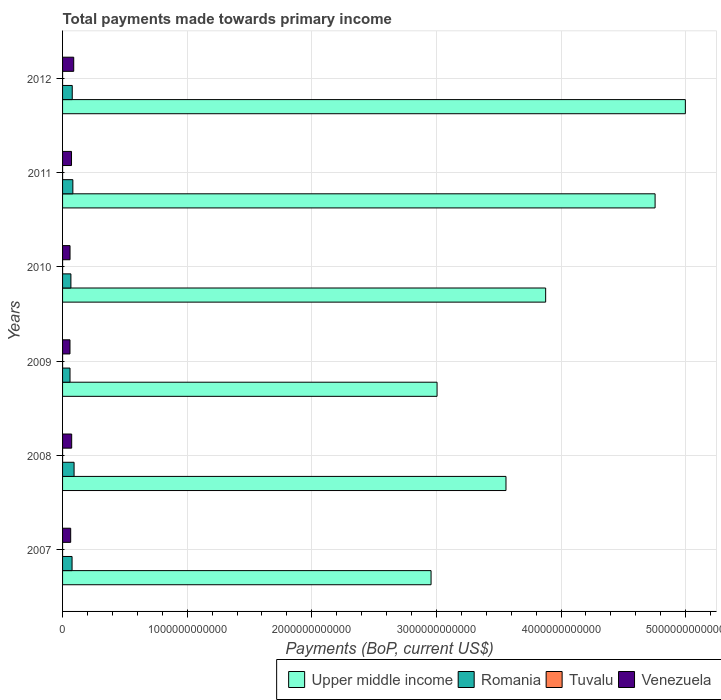How many groups of bars are there?
Keep it short and to the point. 6. Are the number of bars per tick equal to the number of legend labels?
Provide a short and direct response. Yes. Are the number of bars on each tick of the Y-axis equal?
Your response must be concise. Yes. How many bars are there on the 5th tick from the bottom?
Keep it short and to the point. 4. In how many cases, is the number of bars for a given year not equal to the number of legend labels?
Provide a short and direct response. 0. What is the total payments made towards primary income in Venezuela in 2010?
Provide a succinct answer. 5.99e+1. Across all years, what is the maximum total payments made towards primary income in Upper middle income?
Offer a terse response. 5.00e+12. Across all years, what is the minimum total payments made towards primary income in Romania?
Provide a succinct answer. 5.98e+1. In which year was the total payments made towards primary income in Tuvalu maximum?
Offer a very short reply. 2011. In which year was the total payments made towards primary income in Romania minimum?
Provide a short and direct response. 2009. What is the total total payments made towards primary income in Upper middle income in the graph?
Give a very brief answer. 2.32e+13. What is the difference between the total payments made towards primary income in Romania in 2008 and that in 2011?
Offer a very short reply. 9.68e+09. What is the difference between the total payments made towards primary income in Romania in 2009 and the total payments made towards primary income in Tuvalu in 2012?
Keep it short and to the point. 5.98e+1. What is the average total payments made towards primary income in Venezuela per year?
Provide a succinct answer. 6.99e+1. In the year 2012, what is the difference between the total payments made towards primary income in Tuvalu and total payments made towards primary income in Venezuela?
Offer a terse response. -8.95e+1. What is the ratio of the total payments made towards primary income in Tuvalu in 2008 to that in 2010?
Offer a terse response. 0.74. What is the difference between the highest and the second highest total payments made towards primary income in Tuvalu?
Offer a terse response. 1.28e+07. What is the difference between the highest and the lowest total payments made towards primary income in Venezuela?
Give a very brief answer. 3.00e+1. In how many years, is the total payments made towards primary income in Venezuela greater than the average total payments made towards primary income in Venezuela taken over all years?
Keep it short and to the point. 3. Is the sum of the total payments made towards primary income in Upper middle income in 2010 and 2012 greater than the maximum total payments made towards primary income in Tuvalu across all years?
Your response must be concise. Yes. Is it the case that in every year, the sum of the total payments made towards primary income in Tuvalu and total payments made towards primary income in Upper middle income is greater than the sum of total payments made towards primary income in Venezuela and total payments made towards primary income in Romania?
Keep it short and to the point. Yes. What does the 4th bar from the top in 2009 represents?
Your answer should be compact. Upper middle income. What does the 1st bar from the bottom in 2010 represents?
Offer a terse response. Upper middle income. Is it the case that in every year, the sum of the total payments made towards primary income in Upper middle income and total payments made towards primary income in Tuvalu is greater than the total payments made towards primary income in Venezuela?
Give a very brief answer. Yes. How many bars are there?
Offer a terse response. 24. Are all the bars in the graph horizontal?
Offer a terse response. Yes. How many years are there in the graph?
Provide a succinct answer. 6. What is the difference between two consecutive major ticks on the X-axis?
Your answer should be compact. 1.00e+12. Are the values on the major ticks of X-axis written in scientific E-notation?
Provide a succinct answer. No. Does the graph contain grids?
Give a very brief answer. Yes. How are the legend labels stacked?
Your answer should be very brief. Horizontal. What is the title of the graph?
Your answer should be compact. Total payments made towards primary income. What is the label or title of the X-axis?
Your response must be concise. Payments (BoP, current US$). What is the label or title of the Y-axis?
Provide a short and direct response. Years. What is the Payments (BoP, current US$) of Upper middle income in 2007?
Your answer should be compact. 2.96e+12. What is the Payments (BoP, current US$) in Romania in 2007?
Provide a succinct answer. 7.62e+1. What is the Payments (BoP, current US$) of Tuvalu in 2007?
Offer a very short reply. 3.24e+07. What is the Payments (BoP, current US$) in Venezuela in 2007?
Give a very brief answer. 6.52e+1. What is the Payments (BoP, current US$) of Upper middle income in 2008?
Provide a succinct answer. 3.56e+12. What is the Payments (BoP, current US$) of Romania in 2008?
Offer a terse response. 9.23e+1. What is the Payments (BoP, current US$) of Tuvalu in 2008?
Ensure brevity in your answer.  4.03e+07. What is the Payments (BoP, current US$) in Venezuela in 2008?
Make the answer very short. 7.31e+1. What is the Payments (BoP, current US$) in Upper middle income in 2009?
Make the answer very short. 3.01e+12. What is the Payments (BoP, current US$) in Romania in 2009?
Provide a succinct answer. 5.98e+1. What is the Payments (BoP, current US$) of Tuvalu in 2009?
Offer a terse response. 5.19e+07. What is the Payments (BoP, current US$) in Venezuela in 2009?
Your response must be concise. 5.95e+1. What is the Payments (BoP, current US$) in Upper middle income in 2010?
Give a very brief answer. 3.88e+12. What is the Payments (BoP, current US$) in Romania in 2010?
Give a very brief answer. 6.70e+1. What is the Payments (BoP, current US$) in Tuvalu in 2010?
Ensure brevity in your answer.  5.47e+07. What is the Payments (BoP, current US$) of Venezuela in 2010?
Offer a terse response. 5.99e+1. What is the Payments (BoP, current US$) of Upper middle income in 2011?
Your answer should be compact. 4.76e+12. What is the Payments (BoP, current US$) in Romania in 2011?
Offer a terse response. 8.27e+1. What is the Payments (BoP, current US$) in Tuvalu in 2011?
Give a very brief answer. 6.75e+07. What is the Payments (BoP, current US$) of Venezuela in 2011?
Provide a short and direct response. 7.19e+1. What is the Payments (BoP, current US$) of Upper middle income in 2012?
Your answer should be compact. 5.00e+12. What is the Payments (BoP, current US$) in Romania in 2012?
Your answer should be compact. 7.77e+1. What is the Payments (BoP, current US$) in Tuvalu in 2012?
Ensure brevity in your answer.  5.44e+07. What is the Payments (BoP, current US$) in Venezuela in 2012?
Provide a succinct answer. 8.95e+1. Across all years, what is the maximum Payments (BoP, current US$) in Upper middle income?
Your answer should be compact. 5.00e+12. Across all years, what is the maximum Payments (BoP, current US$) of Romania?
Provide a succinct answer. 9.23e+1. Across all years, what is the maximum Payments (BoP, current US$) of Tuvalu?
Keep it short and to the point. 6.75e+07. Across all years, what is the maximum Payments (BoP, current US$) of Venezuela?
Offer a very short reply. 8.95e+1. Across all years, what is the minimum Payments (BoP, current US$) in Upper middle income?
Provide a short and direct response. 2.96e+12. Across all years, what is the minimum Payments (BoP, current US$) in Romania?
Provide a succinct answer. 5.98e+1. Across all years, what is the minimum Payments (BoP, current US$) of Tuvalu?
Your response must be concise. 3.24e+07. Across all years, what is the minimum Payments (BoP, current US$) of Venezuela?
Your answer should be compact. 5.95e+1. What is the total Payments (BoP, current US$) in Upper middle income in the graph?
Provide a succinct answer. 2.32e+13. What is the total Payments (BoP, current US$) of Romania in the graph?
Provide a short and direct response. 4.56e+11. What is the total Payments (BoP, current US$) of Tuvalu in the graph?
Provide a short and direct response. 3.01e+08. What is the total Payments (BoP, current US$) in Venezuela in the graph?
Keep it short and to the point. 4.19e+11. What is the difference between the Payments (BoP, current US$) in Upper middle income in 2007 and that in 2008?
Make the answer very short. -6.01e+11. What is the difference between the Payments (BoP, current US$) in Romania in 2007 and that in 2008?
Your answer should be compact. -1.61e+1. What is the difference between the Payments (BoP, current US$) of Tuvalu in 2007 and that in 2008?
Provide a short and direct response. -7.85e+06. What is the difference between the Payments (BoP, current US$) in Venezuela in 2007 and that in 2008?
Offer a very short reply. -7.94e+09. What is the difference between the Payments (BoP, current US$) of Upper middle income in 2007 and that in 2009?
Your response must be concise. -4.81e+1. What is the difference between the Payments (BoP, current US$) of Romania in 2007 and that in 2009?
Ensure brevity in your answer.  1.64e+1. What is the difference between the Payments (BoP, current US$) of Tuvalu in 2007 and that in 2009?
Provide a short and direct response. -1.95e+07. What is the difference between the Payments (BoP, current US$) in Venezuela in 2007 and that in 2009?
Provide a short and direct response. 5.68e+09. What is the difference between the Payments (BoP, current US$) of Upper middle income in 2007 and that in 2010?
Make the answer very short. -9.20e+11. What is the difference between the Payments (BoP, current US$) in Romania in 2007 and that in 2010?
Keep it short and to the point. 9.24e+09. What is the difference between the Payments (BoP, current US$) of Tuvalu in 2007 and that in 2010?
Give a very brief answer. -2.22e+07. What is the difference between the Payments (BoP, current US$) in Venezuela in 2007 and that in 2010?
Keep it short and to the point. 5.32e+09. What is the difference between the Payments (BoP, current US$) in Upper middle income in 2007 and that in 2011?
Make the answer very short. -1.80e+12. What is the difference between the Payments (BoP, current US$) of Romania in 2007 and that in 2011?
Offer a very short reply. -6.46e+09. What is the difference between the Payments (BoP, current US$) of Tuvalu in 2007 and that in 2011?
Make the answer very short. -3.51e+07. What is the difference between the Payments (BoP, current US$) in Venezuela in 2007 and that in 2011?
Keep it short and to the point. -6.66e+09. What is the difference between the Payments (BoP, current US$) of Upper middle income in 2007 and that in 2012?
Provide a short and direct response. -2.04e+12. What is the difference between the Payments (BoP, current US$) in Romania in 2007 and that in 2012?
Provide a short and direct response. -1.47e+09. What is the difference between the Payments (BoP, current US$) of Tuvalu in 2007 and that in 2012?
Your response must be concise. -2.20e+07. What is the difference between the Payments (BoP, current US$) in Venezuela in 2007 and that in 2012?
Provide a short and direct response. -2.43e+1. What is the difference between the Payments (BoP, current US$) in Upper middle income in 2008 and that in 2009?
Give a very brief answer. 5.53e+11. What is the difference between the Payments (BoP, current US$) of Romania in 2008 and that in 2009?
Your answer should be compact. 3.25e+1. What is the difference between the Payments (BoP, current US$) of Tuvalu in 2008 and that in 2009?
Offer a terse response. -1.16e+07. What is the difference between the Payments (BoP, current US$) of Venezuela in 2008 and that in 2009?
Keep it short and to the point. 1.36e+1. What is the difference between the Payments (BoP, current US$) in Upper middle income in 2008 and that in 2010?
Make the answer very short. -3.18e+11. What is the difference between the Payments (BoP, current US$) in Romania in 2008 and that in 2010?
Provide a succinct answer. 2.54e+1. What is the difference between the Payments (BoP, current US$) of Tuvalu in 2008 and that in 2010?
Provide a short and direct response. -1.44e+07. What is the difference between the Payments (BoP, current US$) of Venezuela in 2008 and that in 2010?
Offer a very short reply. 1.33e+1. What is the difference between the Payments (BoP, current US$) in Upper middle income in 2008 and that in 2011?
Your answer should be very brief. -1.20e+12. What is the difference between the Payments (BoP, current US$) of Romania in 2008 and that in 2011?
Offer a terse response. 9.68e+09. What is the difference between the Payments (BoP, current US$) in Tuvalu in 2008 and that in 2011?
Give a very brief answer. -2.72e+07. What is the difference between the Payments (BoP, current US$) in Venezuela in 2008 and that in 2011?
Give a very brief answer. 1.28e+09. What is the difference between the Payments (BoP, current US$) in Upper middle income in 2008 and that in 2012?
Offer a very short reply. -1.44e+12. What is the difference between the Payments (BoP, current US$) in Romania in 2008 and that in 2012?
Your answer should be very brief. 1.47e+1. What is the difference between the Payments (BoP, current US$) of Tuvalu in 2008 and that in 2012?
Your answer should be compact. -1.41e+07. What is the difference between the Payments (BoP, current US$) of Venezuela in 2008 and that in 2012?
Your answer should be compact. -1.64e+1. What is the difference between the Payments (BoP, current US$) of Upper middle income in 2009 and that in 2010?
Your response must be concise. -8.71e+11. What is the difference between the Payments (BoP, current US$) in Romania in 2009 and that in 2010?
Your answer should be compact. -7.15e+09. What is the difference between the Payments (BoP, current US$) in Tuvalu in 2009 and that in 2010?
Offer a terse response. -2.75e+06. What is the difference between the Payments (BoP, current US$) of Venezuela in 2009 and that in 2010?
Provide a short and direct response. -3.62e+08. What is the difference between the Payments (BoP, current US$) in Upper middle income in 2009 and that in 2011?
Make the answer very short. -1.75e+12. What is the difference between the Payments (BoP, current US$) in Romania in 2009 and that in 2011?
Your answer should be compact. -2.29e+1. What is the difference between the Payments (BoP, current US$) in Tuvalu in 2009 and that in 2011?
Offer a terse response. -1.56e+07. What is the difference between the Payments (BoP, current US$) in Venezuela in 2009 and that in 2011?
Offer a very short reply. -1.23e+1. What is the difference between the Payments (BoP, current US$) in Upper middle income in 2009 and that in 2012?
Give a very brief answer. -1.99e+12. What is the difference between the Payments (BoP, current US$) of Romania in 2009 and that in 2012?
Offer a very short reply. -1.79e+1. What is the difference between the Payments (BoP, current US$) of Tuvalu in 2009 and that in 2012?
Provide a succinct answer. -2.47e+06. What is the difference between the Payments (BoP, current US$) of Venezuela in 2009 and that in 2012?
Your answer should be very brief. -3.00e+1. What is the difference between the Payments (BoP, current US$) of Upper middle income in 2010 and that in 2011?
Keep it short and to the point. -8.78e+11. What is the difference between the Payments (BoP, current US$) of Romania in 2010 and that in 2011?
Keep it short and to the point. -1.57e+1. What is the difference between the Payments (BoP, current US$) of Tuvalu in 2010 and that in 2011?
Offer a terse response. -1.28e+07. What is the difference between the Payments (BoP, current US$) in Venezuela in 2010 and that in 2011?
Give a very brief answer. -1.20e+1. What is the difference between the Payments (BoP, current US$) in Upper middle income in 2010 and that in 2012?
Give a very brief answer. -1.12e+12. What is the difference between the Payments (BoP, current US$) of Romania in 2010 and that in 2012?
Provide a short and direct response. -1.07e+1. What is the difference between the Payments (BoP, current US$) of Tuvalu in 2010 and that in 2012?
Your answer should be very brief. 2.85e+05. What is the difference between the Payments (BoP, current US$) in Venezuela in 2010 and that in 2012?
Your answer should be very brief. -2.97e+1. What is the difference between the Payments (BoP, current US$) of Upper middle income in 2011 and that in 2012?
Provide a short and direct response. -2.43e+11. What is the difference between the Payments (BoP, current US$) in Romania in 2011 and that in 2012?
Keep it short and to the point. 4.99e+09. What is the difference between the Payments (BoP, current US$) of Tuvalu in 2011 and that in 2012?
Your response must be concise. 1.31e+07. What is the difference between the Payments (BoP, current US$) of Venezuela in 2011 and that in 2012?
Give a very brief answer. -1.77e+1. What is the difference between the Payments (BoP, current US$) in Upper middle income in 2007 and the Payments (BoP, current US$) in Romania in 2008?
Your answer should be compact. 2.86e+12. What is the difference between the Payments (BoP, current US$) in Upper middle income in 2007 and the Payments (BoP, current US$) in Tuvalu in 2008?
Ensure brevity in your answer.  2.96e+12. What is the difference between the Payments (BoP, current US$) in Upper middle income in 2007 and the Payments (BoP, current US$) in Venezuela in 2008?
Keep it short and to the point. 2.88e+12. What is the difference between the Payments (BoP, current US$) of Romania in 2007 and the Payments (BoP, current US$) of Tuvalu in 2008?
Give a very brief answer. 7.62e+1. What is the difference between the Payments (BoP, current US$) of Romania in 2007 and the Payments (BoP, current US$) of Venezuela in 2008?
Give a very brief answer. 3.06e+09. What is the difference between the Payments (BoP, current US$) of Tuvalu in 2007 and the Payments (BoP, current US$) of Venezuela in 2008?
Provide a succinct answer. -7.31e+1. What is the difference between the Payments (BoP, current US$) of Upper middle income in 2007 and the Payments (BoP, current US$) of Romania in 2009?
Provide a succinct answer. 2.90e+12. What is the difference between the Payments (BoP, current US$) in Upper middle income in 2007 and the Payments (BoP, current US$) in Tuvalu in 2009?
Your answer should be very brief. 2.96e+12. What is the difference between the Payments (BoP, current US$) of Upper middle income in 2007 and the Payments (BoP, current US$) of Venezuela in 2009?
Keep it short and to the point. 2.90e+12. What is the difference between the Payments (BoP, current US$) in Romania in 2007 and the Payments (BoP, current US$) in Tuvalu in 2009?
Give a very brief answer. 7.62e+1. What is the difference between the Payments (BoP, current US$) in Romania in 2007 and the Payments (BoP, current US$) in Venezuela in 2009?
Your answer should be compact. 1.67e+1. What is the difference between the Payments (BoP, current US$) in Tuvalu in 2007 and the Payments (BoP, current US$) in Venezuela in 2009?
Your response must be concise. -5.95e+1. What is the difference between the Payments (BoP, current US$) in Upper middle income in 2007 and the Payments (BoP, current US$) in Romania in 2010?
Offer a terse response. 2.89e+12. What is the difference between the Payments (BoP, current US$) of Upper middle income in 2007 and the Payments (BoP, current US$) of Tuvalu in 2010?
Ensure brevity in your answer.  2.96e+12. What is the difference between the Payments (BoP, current US$) of Upper middle income in 2007 and the Payments (BoP, current US$) of Venezuela in 2010?
Your response must be concise. 2.90e+12. What is the difference between the Payments (BoP, current US$) in Romania in 2007 and the Payments (BoP, current US$) in Tuvalu in 2010?
Make the answer very short. 7.62e+1. What is the difference between the Payments (BoP, current US$) of Romania in 2007 and the Payments (BoP, current US$) of Venezuela in 2010?
Make the answer very short. 1.63e+1. What is the difference between the Payments (BoP, current US$) of Tuvalu in 2007 and the Payments (BoP, current US$) of Venezuela in 2010?
Make the answer very short. -5.98e+1. What is the difference between the Payments (BoP, current US$) of Upper middle income in 2007 and the Payments (BoP, current US$) of Romania in 2011?
Your answer should be compact. 2.87e+12. What is the difference between the Payments (BoP, current US$) of Upper middle income in 2007 and the Payments (BoP, current US$) of Tuvalu in 2011?
Your answer should be compact. 2.96e+12. What is the difference between the Payments (BoP, current US$) in Upper middle income in 2007 and the Payments (BoP, current US$) in Venezuela in 2011?
Give a very brief answer. 2.89e+12. What is the difference between the Payments (BoP, current US$) of Romania in 2007 and the Payments (BoP, current US$) of Tuvalu in 2011?
Keep it short and to the point. 7.61e+1. What is the difference between the Payments (BoP, current US$) of Romania in 2007 and the Payments (BoP, current US$) of Venezuela in 2011?
Offer a terse response. 4.34e+09. What is the difference between the Payments (BoP, current US$) in Tuvalu in 2007 and the Payments (BoP, current US$) in Venezuela in 2011?
Make the answer very short. -7.18e+1. What is the difference between the Payments (BoP, current US$) in Upper middle income in 2007 and the Payments (BoP, current US$) in Romania in 2012?
Your answer should be compact. 2.88e+12. What is the difference between the Payments (BoP, current US$) of Upper middle income in 2007 and the Payments (BoP, current US$) of Tuvalu in 2012?
Give a very brief answer. 2.96e+12. What is the difference between the Payments (BoP, current US$) in Upper middle income in 2007 and the Payments (BoP, current US$) in Venezuela in 2012?
Your response must be concise. 2.87e+12. What is the difference between the Payments (BoP, current US$) in Romania in 2007 and the Payments (BoP, current US$) in Tuvalu in 2012?
Your answer should be compact. 7.62e+1. What is the difference between the Payments (BoP, current US$) of Romania in 2007 and the Payments (BoP, current US$) of Venezuela in 2012?
Your answer should be very brief. -1.33e+1. What is the difference between the Payments (BoP, current US$) of Tuvalu in 2007 and the Payments (BoP, current US$) of Venezuela in 2012?
Offer a very short reply. -8.95e+1. What is the difference between the Payments (BoP, current US$) in Upper middle income in 2008 and the Payments (BoP, current US$) in Romania in 2009?
Offer a terse response. 3.50e+12. What is the difference between the Payments (BoP, current US$) of Upper middle income in 2008 and the Payments (BoP, current US$) of Tuvalu in 2009?
Ensure brevity in your answer.  3.56e+12. What is the difference between the Payments (BoP, current US$) in Upper middle income in 2008 and the Payments (BoP, current US$) in Venezuela in 2009?
Make the answer very short. 3.50e+12. What is the difference between the Payments (BoP, current US$) in Romania in 2008 and the Payments (BoP, current US$) in Tuvalu in 2009?
Your response must be concise. 9.23e+1. What is the difference between the Payments (BoP, current US$) of Romania in 2008 and the Payments (BoP, current US$) of Venezuela in 2009?
Offer a terse response. 3.28e+1. What is the difference between the Payments (BoP, current US$) of Tuvalu in 2008 and the Payments (BoP, current US$) of Venezuela in 2009?
Provide a succinct answer. -5.95e+1. What is the difference between the Payments (BoP, current US$) in Upper middle income in 2008 and the Payments (BoP, current US$) in Romania in 2010?
Provide a succinct answer. 3.49e+12. What is the difference between the Payments (BoP, current US$) in Upper middle income in 2008 and the Payments (BoP, current US$) in Tuvalu in 2010?
Give a very brief answer. 3.56e+12. What is the difference between the Payments (BoP, current US$) in Upper middle income in 2008 and the Payments (BoP, current US$) in Venezuela in 2010?
Make the answer very short. 3.50e+12. What is the difference between the Payments (BoP, current US$) of Romania in 2008 and the Payments (BoP, current US$) of Tuvalu in 2010?
Give a very brief answer. 9.23e+1. What is the difference between the Payments (BoP, current US$) in Romania in 2008 and the Payments (BoP, current US$) in Venezuela in 2010?
Provide a succinct answer. 3.25e+1. What is the difference between the Payments (BoP, current US$) in Tuvalu in 2008 and the Payments (BoP, current US$) in Venezuela in 2010?
Provide a succinct answer. -5.98e+1. What is the difference between the Payments (BoP, current US$) of Upper middle income in 2008 and the Payments (BoP, current US$) of Romania in 2011?
Give a very brief answer. 3.48e+12. What is the difference between the Payments (BoP, current US$) of Upper middle income in 2008 and the Payments (BoP, current US$) of Tuvalu in 2011?
Provide a short and direct response. 3.56e+12. What is the difference between the Payments (BoP, current US$) of Upper middle income in 2008 and the Payments (BoP, current US$) of Venezuela in 2011?
Offer a very short reply. 3.49e+12. What is the difference between the Payments (BoP, current US$) in Romania in 2008 and the Payments (BoP, current US$) in Tuvalu in 2011?
Make the answer very short. 9.23e+1. What is the difference between the Payments (BoP, current US$) in Romania in 2008 and the Payments (BoP, current US$) in Venezuela in 2011?
Offer a very short reply. 2.05e+1. What is the difference between the Payments (BoP, current US$) in Tuvalu in 2008 and the Payments (BoP, current US$) in Venezuela in 2011?
Your response must be concise. -7.18e+1. What is the difference between the Payments (BoP, current US$) in Upper middle income in 2008 and the Payments (BoP, current US$) in Romania in 2012?
Your answer should be compact. 3.48e+12. What is the difference between the Payments (BoP, current US$) in Upper middle income in 2008 and the Payments (BoP, current US$) in Tuvalu in 2012?
Give a very brief answer. 3.56e+12. What is the difference between the Payments (BoP, current US$) in Upper middle income in 2008 and the Payments (BoP, current US$) in Venezuela in 2012?
Your response must be concise. 3.47e+12. What is the difference between the Payments (BoP, current US$) in Romania in 2008 and the Payments (BoP, current US$) in Tuvalu in 2012?
Make the answer very short. 9.23e+1. What is the difference between the Payments (BoP, current US$) of Romania in 2008 and the Payments (BoP, current US$) of Venezuela in 2012?
Provide a short and direct response. 2.79e+09. What is the difference between the Payments (BoP, current US$) in Tuvalu in 2008 and the Payments (BoP, current US$) in Venezuela in 2012?
Make the answer very short. -8.95e+1. What is the difference between the Payments (BoP, current US$) of Upper middle income in 2009 and the Payments (BoP, current US$) of Romania in 2010?
Your answer should be very brief. 2.94e+12. What is the difference between the Payments (BoP, current US$) in Upper middle income in 2009 and the Payments (BoP, current US$) in Tuvalu in 2010?
Offer a terse response. 3.01e+12. What is the difference between the Payments (BoP, current US$) in Upper middle income in 2009 and the Payments (BoP, current US$) in Venezuela in 2010?
Make the answer very short. 2.95e+12. What is the difference between the Payments (BoP, current US$) of Romania in 2009 and the Payments (BoP, current US$) of Tuvalu in 2010?
Your answer should be compact. 5.98e+1. What is the difference between the Payments (BoP, current US$) in Romania in 2009 and the Payments (BoP, current US$) in Venezuela in 2010?
Give a very brief answer. -6.60e+07. What is the difference between the Payments (BoP, current US$) in Tuvalu in 2009 and the Payments (BoP, current US$) in Venezuela in 2010?
Ensure brevity in your answer.  -5.98e+1. What is the difference between the Payments (BoP, current US$) in Upper middle income in 2009 and the Payments (BoP, current US$) in Romania in 2011?
Keep it short and to the point. 2.92e+12. What is the difference between the Payments (BoP, current US$) in Upper middle income in 2009 and the Payments (BoP, current US$) in Tuvalu in 2011?
Provide a short and direct response. 3.01e+12. What is the difference between the Payments (BoP, current US$) of Upper middle income in 2009 and the Payments (BoP, current US$) of Venezuela in 2011?
Make the answer very short. 2.93e+12. What is the difference between the Payments (BoP, current US$) of Romania in 2009 and the Payments (BoP, current US$) of Tuvalu in 2011?
Make the answer very short. 5.97e+1. What is the difference between the Payments (BoP, current US$) of Romania in 2009 and the Payments (BoP, current US$) of Venezuela in 2011?
Your response must be concise. -1.21e+1. What is the difference between the Payments (BoP, current US$) of Tuvalu in 2009 and the Payments (BoP, current US$) of Venezuela in 2011?
Offer a very short reply. -7.18e+1. What is the difference between the Payments (BoP, current US$) of Upper middle income in 2009 and the Payments (BoP, current US$) of Romania in 2012?
Offer a very short reply. 2.93e+12. What is the difference between the Payments (BoP, current US$) of Upper middle income in 2009 and the Payments (BoP, current US$) of Tuvalu in 2012?
Your response must be concise. 3.01e+12. What is the difference between the Payments (BoP, current US$) in Upper middle income in 2009 and the Payments (BoP, current US$) in Venezuela in 2012?
Give a very brief answer. 2.92e+12. What is the difference between the Payments (BoP, current US$) of Romania in 2009 and the Payments (BoP, current US$) of Tuvalu in 2012?
Keep it short and to the point. 5.98e+1. What is the difference between the Payments (BoP, current US$) of Romania in 2009 and the Payments (BoP, current US$) of Venezuela in 2012?
Ensure brevity in your answer.  -2.97e+1. What is the difference between the Payments (BoP, current US$) in Tuvalu in 2009 and the Payments (BoP, current US$) in Venezuela in 2012?
Offer a terse response. -8.95e+1. What is the difference between the Payments (BoP, current US$) of Upper middle income in 2010 and the Payments (BoP, current US$) of Romania in 2011?
Provide a short and direct response. 3.79e+12. What is the difference between the Payments (BoP, current US$) of Upper middle income in 2010 and the Payments (BoP, current US$) of Tuvalu in 2011?
Offer a terse response. 3.88e+12. What is the difference between the Payments (BoP, current US$) in Upper middle income in 2010 and the Payments (BoP, current US$) in Venezuela in 2011?
Your answer should be compact. 3.80e+12. What is the difference between the Payments (BoP, current US$) of Romania in 2010 and the Payments (BoP, current US$) of Tuvalu in 2011?
Provide a short and direct response. 6.69e+1. What is the difference between the Payments (BoP, current US$) of Romania in 2010 and the Payments (BoP, current US$) of Venezuela in 2011?
Provide a succinct answer. -4.90e+09. What is the difference between the Payments (BoP, current US$) of Tuvalu in 2010 and the Payments (BoP, current US$) of Venezuela in 2011?
Your answer should be compact. -7.18e+1. What is the difference between the Payments (BoP, current US$) in Upper middle income in 2010 and the Payments (BoP, current US$) in Romania in 2012?
Keep it short and to the point. 3.80e+12. What is the difference between the Payments (BoP, current US$) in Upper middle income in 2010 and the Payments (BoP, current US$) in Tuvalu in 2012?
Your answer should be very brief. 3.88e+12. What is the difference between the Payments (BoP, current US$) of Upper middle income in 2010 and the Payments (BoP, current US$) of Venezuela in 2012?
Your response must be concise. 3.79e+12. What is the difference between the Payments (BoP, current US$) in Romania in 2010 and the Payments (BoP, current US$) in Tuvalu in 2012?
Make the answer very short. 6.69e+1. What is the difference between the Payments (BoP, current US$) in Romania in 2010 and the Payments (BoP, current US$) in Venezuela in 2012?
Offer a terse response. -2.26e+1. What is the difference between the Payments (BoP, current US$) in Tuvalu in 2010 and the Payments (BoP, current US$) in Venezuela in 2012?
Keep it short and to the point. -8.95e+1. What is the difference between the Payments (BoP, current US$) of Upper middle income in 2011 and the Payments (BoP, current US$) of Romania in 2012?
Offer a terse response. 4.68e+12. What is the difference between the Payments (BoP, current US$) in Upper middle income in 2011 and the Payments (BoP, current US$) in Tuvalu in 2012?
Offer a terse response. 4.75e+12. What is the difference between the Payments (BoP, current US$) of Upper middle income in 2011 and the Payments (BoP, current US$) of Venezuela in 2012?
Give a very brief answer. 4.67e+12. What is the difference between the Payments (BoP, current US$) of Romania in 2011 and the Payments (BoP, current US$) of Tuvalu in 2012?
Offer a very short reply. 8.26e+1. What is the difference between the Payments (BoP, current US$) in Romania in 2011 and the Payments (BoP, current US$) in Venezuela in 2012?
Offer a very short reply. -6.88e+09. What is the difference between the Payments (BoP, current US$) of Tuvalu in 2011 and the Payments (BoP, current US$) of Venezuela in 2012?
Keep it short and to the point. -8.95e+1. What is the average Payments (BoP, current US$) in Upper middle income per year?
Your answer should be very brief. 3.86e+12. What is the average Payments (BoP, current US$) in Romania per year?
Keep it short and to the point. 7.59e+1. What is the average Payments (BoP, current US$) in Tuvalu per year?
Ensure brevity in your answer.  5.02e+07. What is the average Payments (BoP, current US$) of Venezuela per year?
Offer a terse response. 6.99e+1. In the year 2007, what is the difference between the Payments (BoP, current US$) in Upper middle income and Payments (BoP, current US$) in Romania?
Give a very brief answer. 2.88e+12. In the year 2007, what is the difference between the Payments (BoP, current US$) of Upper middle income and Payments (BoP, current US$) of Tuvalu?
Provide a succinct answer. 2.96e+12. In the year 2007, what is the difference between the Payments (BoP, current US$) of Upper middle income and Payments (BoP, current US$) of Venezuela?
Make the answer very short. 2.89e+12. In the year 2007, what is the difference between the Payments (BoP, current US$) of Romania and Payments (BoP, current US$) of Tuvalu?
Your answer should be very brief. 7.62e+1. In the year 2007, what is the difference between the Payments (BoP, current US$) of Romania and Payments (BoP, current US$) of Venezuela?
Your answer should be very brief. 1.10e+1. In the year 2007, what is the difference between the Payments (BoP, current US$) in Tuvalu and Payments (BoP, current US$) in Venezuela?
Give a very brief answer. -6.52e+1. In the year 2008, what is the difference between the Payments (BoP, current US$) of Upper middle income and Payments (BoP, current US$) of Romania?
Ensure brevity in your answer.  3.47e+12. In the year 2008, what is the difference between the Payments (BoP, current US$) in Upper middle income and Payments (BoP, current US$) in Tuvalu?
Your answer should be compact. 3.56e+12. In the year 2008, what is the difference between the Payments (BoP, current US$) in Upper middle income and Payments (BoP, current US$) in Venezuela?
Your answer should be compact. 3.49e+12. In the year 2008, what is the difference between the Payments (BoP, current US$) in Romania and Payments (BoP, current US$) in Tuvalu?
Your response must be concise. 9.23e+1. In the year 2008, what is the difference between the Payments (BoP, current US$) in Romania and Payments (BoP, current US$) in Venezuela?
Your answer should be very brief. 1.92e+1. In the year 2008, what is the difference between the Payments (BoP, current US$) in Tuvalu and Payments (BoP, current US$) in Venezuela?
Provide a short and direct response. -7.31e+1. In the year 2009, what is the difference between the Payments (BoP, current US$) of Upper middle income and Payments (BoP, current US$) of Romania?
Make the answer very short. 2.95e+12. In the year 2009, what is the difference between the Payments (BoP, current US$) of Upper middle income and Payments (BoP, current US$) of Tuvalu?
Your response must be concise. 3.01e+12. In the year 2009, what is the difference between the Payments (BoP, current US$) of Upper middle income and Payments (BoP, current US$) of Venezuela?
Your answer should be compact. 2.95e+12. In the year 2009, what is the difference between the Payments (BoP, current US$) in Romania and Payments (BoP, current US$) in Tuvalu?
Keep it short and to the point. 5.98e+1. In the year 2009, what is the difference between the Payments (BoP, current US$) in Romania and Payments (BoP, current US$) in Venezuela?
Offer a very short reply. 2.96e+08. In the year 2009, what is the difference between the Payments (BoP, current US$) of Tuvalu and Payments (BoP, current US$) of Venezuela?
Provide a short and direct response. -5.95e+1. In the year 2010, what is the difference between the Payments (BoP, current US$) in Upper middle income and Payments (BoP, current US$) in Romania?
Provide a succinct answer. 3.81e+12. In the year 2010, what is the difference between the Payments (BoP, current US$) of Upper middle income and Payments (BoP, current US$) of Tuvalu?
Provide a short and direct response. 3.88e+12. In the year 2010, what is the difference between the Payments (BoP, current US$) of Upper middle income and Payments (BoP, current US$) of Venezuela?
Make the answer very short. 3.82e+12. In the year 2010, what is the difference between the Payments (BoP, current US$) in Romania and Payments (BoP, current US$) in Tuvalu?
Ensure brevity in your answer.  6.69e+1. In the year 2010, what is the difference between the Payments (BoP, current US$) of Romania and Payments (BoP, current US$) of Venezuela?
Provide a short and direct response. 7.09e+09. In the year 2010, what is the difference between the Payments (BoP, current US$) of Tuvalu and Payments (BoP, current US$) of Venezuela?
Make the answer very short. -5.98e+1. In the year 2011, what is the difference between the Payments (BoP, current US$) in Upper middle income and Payments (BoP, current US$) in Romania?
Ensure brevity in your answer.  4.67e+12. In the year 2011, what is the difference between the Payments (BoP, current US$) of Upper middle income and Payments (BoP, current US$) of Tuvalu?
Your answer should be compact. 4.75e+12. In the year 2011, what is the difference between the Payments (BoP, current US$) in Upper middle income and Payments (BoP, current US$) in Venezuela?
Your response must be concise. 4.68e+12. In the year 2011, what is the difference between the Payments (BoP, current US$) of Romania and Payments (BoP, current US$) of Tuvalu?
Your response must be concise. 8.26e+1. In the year 2011, what is the difference between the Payments (BoP, current US$) of Romania and Payments (BoP, current US$) of Venezuela?
Offer a very short reply. 1.08e+1. In the year 2011, what is the difference between the Payments (BoP, current US$) of Tuvalu and Payments (BoP, current US$) of Venezuela?
Offer a very short reply. -7.18e+1. In the year 2012, what is the difference between the Payments (BoP, current US$) of Upper middle income and Payments (BoP, current US$) of Romania?
Offer a very short reply. 4.92e+12. In the year 2012, what is the difference between the Payments (BoP, current US$) of Upper middle income and Payments (BoP, current US$) of Tuvalu?
Keep it short and to the point. 5.00e+12. In the year 2012, what is the difference between the Payments (BoP, current US$) of Upper middle income and Payments (BoP, current US$) of Venezuela?
Provide a short and direct response. 4.91e+12. In the year 2012, what is the difference between the Payments (BoP, current US$) in Romania and Payments (BoP, current US$) in Tuvalu?
Provide a succinct answer. 7.76e+1. In the year 2012, what is the difference between the Payments (BoP, current US$) in Romania and Payments (BoP, current US$) in Venezuela?
Your response must be concise. -1.19e+1. In the year 2012, what is the difference between the Payments (BoP, current US$) of Tuvalu and Payments (BoP, current US$) of Venezuela?
Your response must be concise. -8.95e+1. What is the ratio of the Payments (BoP, current US$) of Upper middle income in 2007 to that in 2008?
Offer a terse response. 0.83. What is the ratio of the Payments (BoP, current US$) of Romania in 2007 to that in 2008?
Offer a terse response. 0.83. What is the ratio of the Payments (BoP, current US$) in Tuvalu in 2007 to that in 2008?
Offer a terse response. 0.81. What is the ratio of the Payments (BoP, current US$) in Venezuela in 2007 to that in 2008?
Provide a succinct answer. 0.89. What is the ratio of the Payments (BoP, current US$) in Upper middle income in 2007 to that in 2009?
Provide a succinct answer. 0.98. What is the ratio of the Payments (BoP, current US$) in Romania in 2007 to that in 2009?
Give a very brief answer. 1.27. What is the ratio of the Payments (BoP, current US$) in Tuvalu in 2007 to that in 2009?
Offer a terse response. 0.62. What is the ratio of the Payments (BoP, current US$) in Venezuela in 2007 to that in 2009?
Offer a terse response. 1.1. What is the ratio of the Payments (BoP, current US$) of Upper middle income in 2007 to that in 2010?
Offer a terse response. 0.76. What is the ratio of the Payments (BoP, current US$) of Romania in 2007 to that in 2010?
Ensure brevity in your answer.  1.14. What is the ratio of the Payments (BoP, current US$) in Tuvalu in 2007 to that in 2010?
Offer a terse response. 0.59. What is the ratio of the Payments (BoP, current US$) in Venezuela in 2007 to that in 2010?
Provide a succinct answer. 1.09. What is the ratio of the Payments (BoP, current US$) of Upper middle income in 2007 to that in 2011?
Offer a very short reply. 0.62. What is the ratio of the Payments (BoP, current US$) of Romania in 2007 to that in 2011?
Keep it short and to the point. 0.92. What is the ratio of the Payments (BoP, current US$) in Tuvalu in 2007 to that in 2011?
Provide a succinct answer. 0.48. What is the ratio of the Payments (BoP, current US$) in Venezuela in 2007 to that in 2011?
Provide a succinct answer. 0.91. What is the ratio of the Payments (BoP, current US$) of Upper middle income in 2007 to that in 2012?
Offer a terse response. 0.59. What is the ratio of the Payments (BoP, current US$) in Romania in 2007 to that in 2012?
Give a very brief answer. 0.98. What is the ratio of the Payments (BoP, current US$) of Tuvalu in 2007 to that in 2012?
Offer a very short reply. 0.6. What is the ratio of the Payments (BoP, current US$) in Venezuela in 2007 to that in 2012?
Keep it short and to the point. 0.73. What is the ratio of the Payments (BoP, current US$) of Upper middle income in 2008 to that in 2009?
Keep it short and to the point. 1.18. What is the ratio of the Payments (BoP, current US$) of Romania in 2008 to that in 2009?
Make the answer very short. 1.54. What is the ratio of the Payments (BoP, current US$) of Tuvalu in 2008 to that in 2009?
Make the answer very short. 0.78. What is the ratio of the Payments (BoP, current US$) in Venezuela in 2008 to that in 2009?
Your response must be concise. 1.23. What is the ratio of the Payments (BoP, current US$) of Upper middle income in 2008 to that in 2010?
Provide a short and direct response. 0.92. What is the ratio of the Payments (BoP, current US$) of Romania in 2008 to that in 2010?
Provide a short and direct response. 1.38. What is the ratio of the Payments (BoP, current US$) in Tuvalu in 2008 to that in 2010?
Make the answer very short. 0.74. What is the ratio of the Payments (BoP, current US$) in Venezuela in 2008 to that in 2010?
Ensure brevity in your answer.  1.22. What is the ratio of the Payments (BoP, current US$) of Upper middle income in 2008 to that in 2011?
Ensure brevity in your answer.  0.75. What is the ratio of the Payments (BoP, current US$) in Romania in 2008 to that in 2011?
Make the answer very short. 1.12. What is the ratio of the Payments (BoP, current US$) of Tuvalu in 2008 to that in 2011?
Provide a short and direct response. 0.6. What is the ratio of the Payments (BoP, current US$) of Venezuela in 2008 to that in 2011?
Offer a terse response. 1.02. What is the ratio of the Payments (BoP, current US$) in Upper middle income in 2008 to that in 2012?
Your response must be concise. 0.71. What is the ratio of the Payments (BoP, current US$) of Romania in 2008 to that in 2012?
Ensure brevity in your answer.  1.19. What is the ratio of the Payments (BoP, current US$) of Tuvalu in 2008 to that in 2012?
Offer a terse response. 0.74. What is the ratio of the Payments (BoP, current US$) of Venezuela in 2008 to that in 2012?
Keep it short and to the point. 0.82. What is the ratio of the Payments (BoP, current US$) of Upper middle income in 2009 to that in 2010?
Offer a very short reply. 0.78. What is the ratio of the Payments (BoP, current US$) in Romania in 2009 to that in 2010?
Make the answer very short. 0.89. What is the ratio of the Payments (BoP, current US$) of Tuvalu in 2009 to that in 2010?
Provide a short and direct response. 0.95. What is the ratio of the Payments (BoP, current US$) of Upper middle income in 2009 to that in 2011?
Offer a very short reply. 0.63. What is the ratio of the Payments (BoP, current US$) in Romania in 2009 to that in 2011?
Give a very brief answer. 0.72. What is the ratio of the Payments (BoP, current US$) of Tuvalu in 2009 to that in 2011?
Your answer should be very brief. 0.77. What is the ratio of the Payments (BoP, current US$) of Venezuela in 2009 to that in 2011?
Provide a short and direct response. 0.83. What is the ratio of the Payments (BoP, current US$) of Upper middle income in 2009 to that in 2012?
Offer a terse response. 0.6. What is the ratio of the Payments (BoP, current US$) in Romania in 2009 to that in 2012?
Your answer should be compact. 0.77. What is the ratio of the Payments (BoP, current US$) in Tuvalu in 2009 to that in 2012?
Offer a very short reply. 0.95. What is the ratio of the Payments (BoP, current US$) in Venezuela in 2009 to that in 2012?
Offer a very short reply. 0.66. What is the ratio of the Payments (BoP, current US$) in Upper middle income in 2010 to that in 2011?
Ensure brevity in your answer.  0.82. What is the ratio of the Payments (BoP, current US$) in Romania in 2010 to that in 2011?
Provide a succinct answer. 0.81. What is the ratio of the Payments (BoP, current US$) of Tuvalu in 2010 to that in 2011?
Offer a terse response. 0.81. What is the ratio of the Payments (BoP, current US$) in Venezuela in 2010 to that in 2011?
Make the answer very short. 0.83. What is the ratio of the Payments (BoP, current US$) of Upper middle income in 2010 to that in 2012?
Give a very brief answer. 0.78. What is the ratio of the Payments (BoP, current US$) of Romania in 2010 to that in 2012?
Your response must be concise. 0.86. What is the ratio of the Payments (BoP, current US$) in Tuvalu in 2010 to that in 2012?
Make the answer very short. 1.01. What is the ratio of the Payments (BoP, current US$) in Venezuela in 2010 to that in 2012?
Make the answer very short. 0.67. What is the ratio of the Payments (BoP, current US$) of Upper middle income in 2011 to that in 2012?
Your answer should be very brief. 0.95. What is the ratio of the Payments (BoP, current US$) in Romania in 2011 to that in 2012?
Your answer should be compact. 1.06. What is the ratio of the Payments (BoP, current US$) of Tuvalu in 2011 to that in 2012?
Keep it short and to the point. 1.24. What is the ratio of the Payments (BoP, current US$) in Venezuela in 2011 to that in 2012?
Your answer should be compact. 0.8. What is the difference between the highest and the second highest Payments (BoP, current US$) of Upper middle income?
Offer a terse response. 2.43e+11. What is the difference between the highest and the second highest Payments (BoP, current US$) in Romania?
Offer a very short reply. 9.68e+09. What is the difference between the highest and the second highest Payments (BoP, current US$) of Tuvalu?
Make the answer very short. 1.28e+07. What is the difference between the highest and the second highest Payments (BoP, current US$) in Venezuela?
Provide a short and direct response. 1.64e+1. What is the difference between the highest and the lowest Payments (BoP, current US$) of Upper middle income?
Your answer should be compact. 2.04e+12. What is the difference between the highest and the lowest Payments (BoP, current US$) of Romania?
Provide a succinct answer. 3.25e+1. What is the difference between the highest and the lowest Payments (BoP, current US$) of Tuvalu?
Give a very brief answer. 3.51e+07. What is the difference between the highest and the lowest Payments (BoP, current US$) of Venezuela?
Provide a succinct answer. 3.00e+1. 